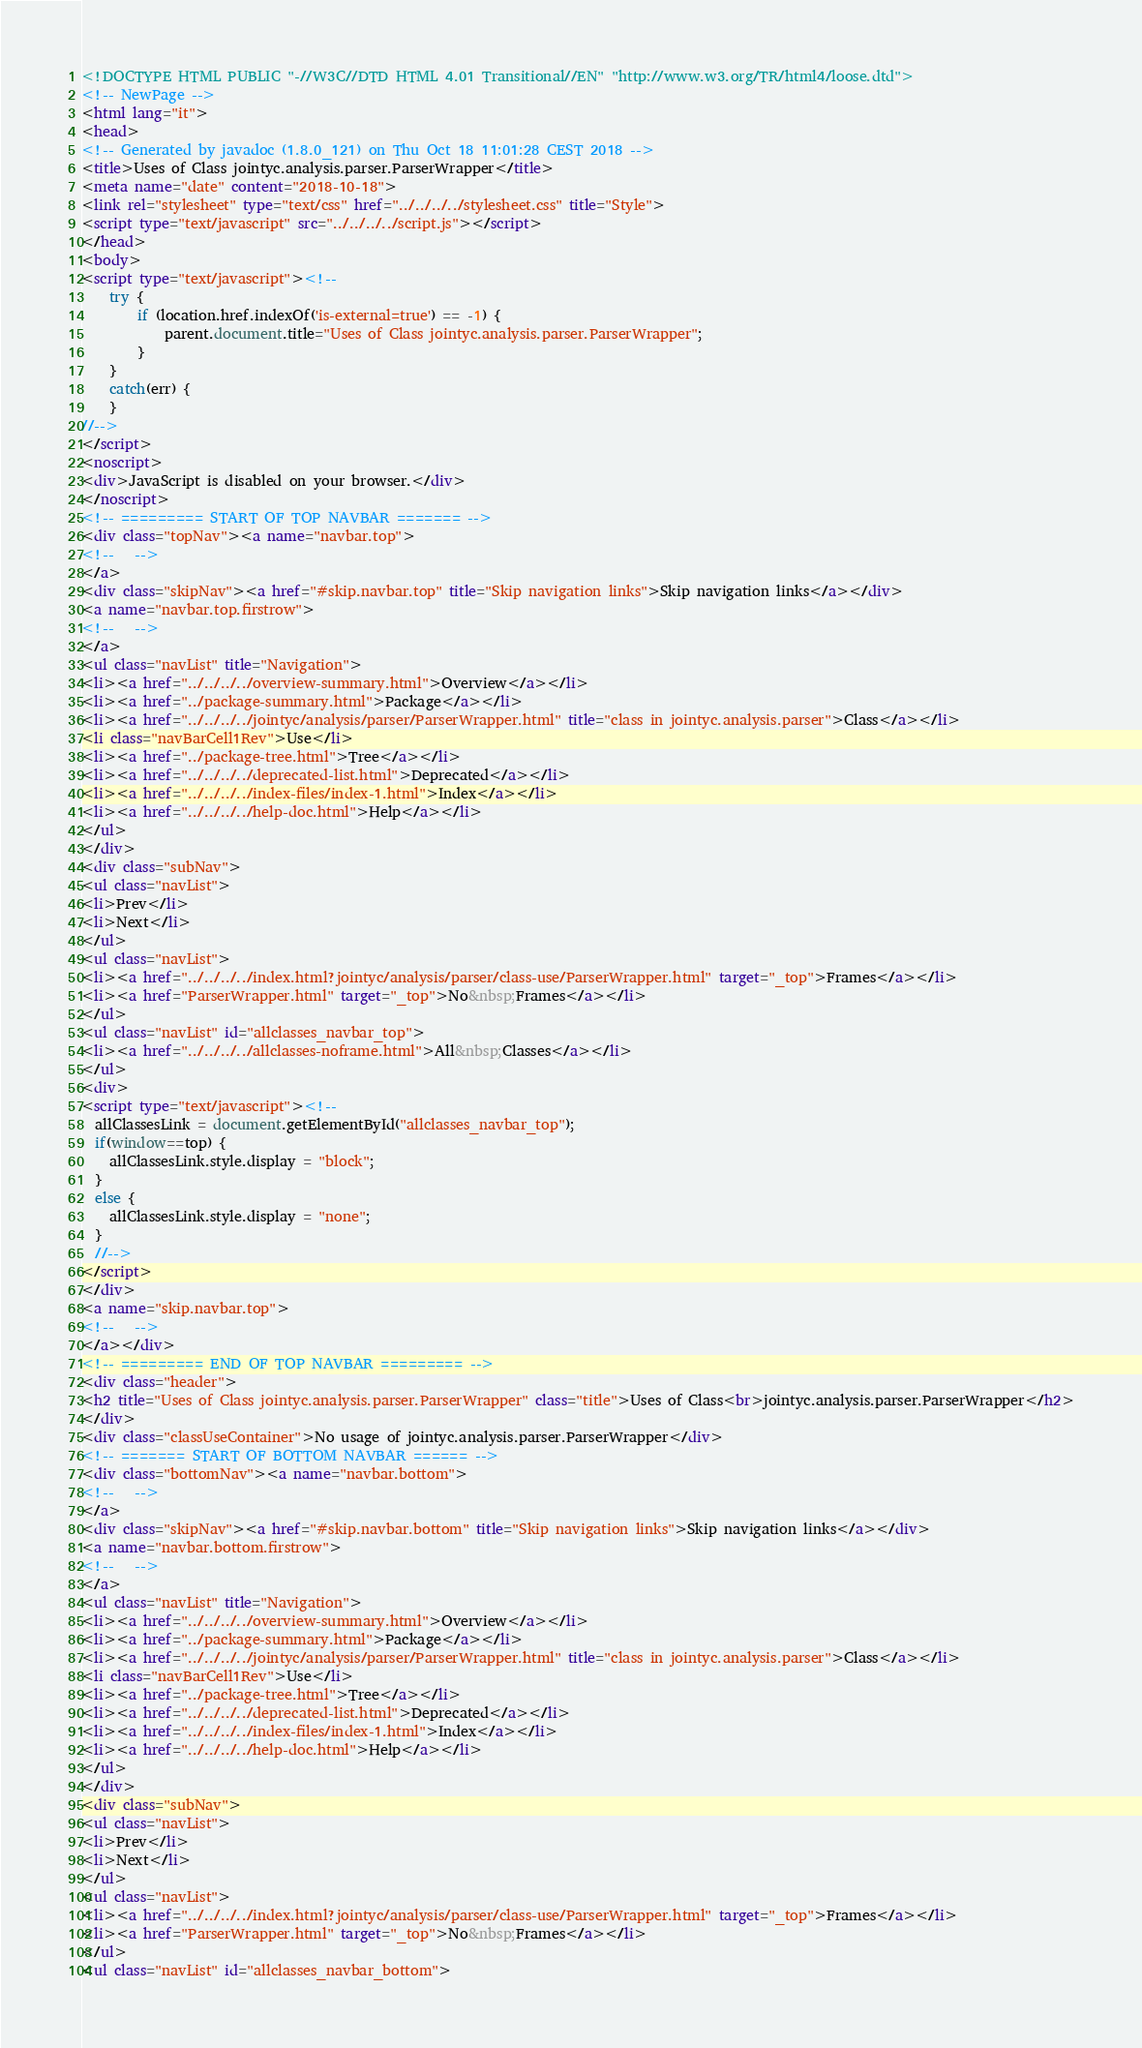Convert code to text. <code><loc_0><loc_0><loc_500><loc_500><_HTML_><!DOCTYPE HTML PUBLIC "-//W3C//DTD HTML 4.01 Transitional//EN" "http://www.w3.org/TR/html4/loose.dtd">
<!-- NewPage -->
<html lang="it">
<head>
<!-- Generated by javadoc (1.8.0_121) on Thu Oct 18 11:01:28 CEST 2018 -->
<title>Uses of Class jointyc.analysis.parser.ParserWrapper</title>
<meta name="date" content="2018-10-18">
<link rel="stylesheet" type="text/css" href="../../../../stylesheet.css" title="Style">
<script type="text/javascript" src="../../../../script.js"></script>
</head>
<body>
<script type="text/javascript"><!--
    try {
        if (location.href.indexOf('is-external=true') == -1) {
            parent.document.title="Uses of Class jointyc.analysis.parser.ParserWrapper";
        }
    }
    catch(err) {
    }
//-->
</script>
<noscript>
<div>JavaScript is disabled on your browser.</div>
</noscript>
<!-- ========= START OF TOP NAVBAR ======= -->
<div class="topNav"><a name="navbar.top">
<!--   -->
</a>
<div class="skipNav"><a href="#skip.navbar.top" title="Skip navigation links">Skip navigation links</a></div>
<a name="navbar.top.firstrow">
<!--   -->
</a>
<ul class="navList" title="Navigation">
<li><a href="../../../../overview-summary.html">Overview</a></li>
<li><a href="../package-summary.html">Package</a></li>
<li><a href="../../../../jointyc/analysis/parser/ParserWrapper.html" title="class in jointyc.analysis.parser">Class</a></li>
<li class="navBarCell1Rev">Use</li>
<li><a href="../package-tree.html">Tree</a></li>
<li><a href="../../../../deprecated-list.html">Deprecated</a></li>
<li><a href="../../../../index-files/index-1.html">Index</a></li>
<li><a href="../../../../help-doc.html">Help</a></li>
</ul>
</div>
<div class="subNav">
<ul class="navList">
<li>Prev</li>
<li>Next</li>
</ul>
<ul class="navList">
<li><a href="../../../../index.html?jointyc/analysis/parser/class-use/ParserWrapper.html" target="_top">Frames</a></li>
<li><a href="ParserWrapper.html" target="_top">No&nbsp;Frames</a></li>
</ul>
<ul class="navList" id="allclasses_navbar_top">
<li><a href="../../../../allclasses-noframe.html">All&nbsp;Classes</a></li>
</ul>
<div>
<script type="text/javascript"><!--
  allClassesLink = document.getElementById("allclasses_navbar_top");
  if(window==top) {
    allClassesLink.style.display = "block";
  }
  else {
    allClassesLink.style.display = "none";
  }
  //-->
</script>
</div>
<a name="skip.navbar.top">
<!--   -->
</a></div>
<!-- ========= END OF TOP NAVBAR ========= -->
<div class="header">
<h2 title="Uses of Class jointyc.analysis.parser.ParserWrapper" class="title">Uses of Class<br>jointyc.analysis.parser.ParserWrapper</h2>
</div>
<div class="classUseContainer">No usage of jointyc.analysis.parser.ParserWrapper</div>
<!-- ======= START OF BOTTOM NAVBAR ====== -->
<div class="bottomNav"><a name="navbar.bottom">
<!--   -->
</a>
<div class="skipNav"><a href="#skip.navbar.bottom" title="Skip navigation links">Skip navigation links</a></div>
<a name="navbar.bottom.firstrow">
<!--   -->
</a>
<ul class="navList" title="Navigation">
<li><a href="../../../../overview-summary.html">Overview</a></li>
<li><a href="../package-summary.html">Package</a></li>
<li><a href="../../../../jointyc/analysis/parser/ParserWrapper.html" title="class in jointyc.analysis.parser">Class</a></li>
<li class="navBarCell1Rev">Use</li>
<li><a href="../package-tree.html">Tree</a></li>
<li><a href="../../../../deprecated-list.html">Deprecated</a></li>
<li><a href="../../../../index-files/index-1.html">Index</a></li>
<li><a href="../../../../help-doc.html">Help</a></li>
</ul>
</div>
<div class="subNav">
<ul class="navList">
<li>Prev</li>
<li>Next</li>
</ul>
<ul class="navList">
<li><a href="../../../../index.html?jointyc/analysis/parser/class-use/ParserWrapper.html" target="_top">Frames</a></li>
<li><a href="ParserWrapper.html" target="_top">No&nbsp;Frames</a></li>
</ul>
<ul class="navList" id="allclasses_navbar_bottom"></code> 